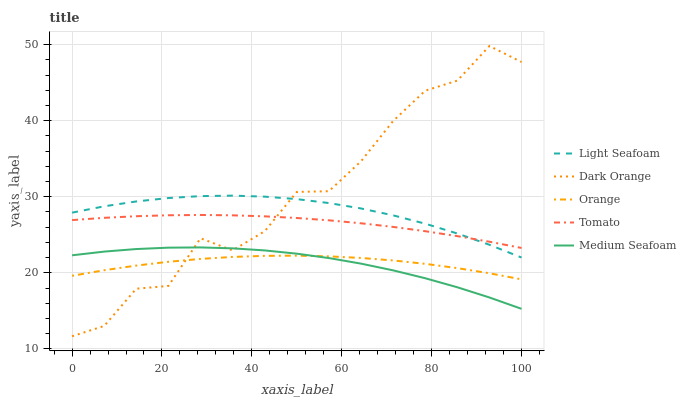Does Medium Seafoam have the minimum area under the curve?
Answer yes or no. Yes. Does Dark Orange have the maximum area under the curve?
Answer yes or no. Yes. Does Tomato have the minimum area under the curve?
Answer yes or no. No. Does Tomato have the maximum area under the curve?
Answer yes or no. No. Is Tomato the smoothest?
Answer yes or no. Yes. Is Dark Orange the roughest?
Answer yes or no. Yes. Is Dark Orange the smoothest?
Answer yes or no. No. Is Tomato the roughest?
Answer yes or no. No. Does Dark Orange have the lowest value?
Answer yes or no. Yes. Does Tomato have the lowest value?
Answer yes or no. No. Does Dark Orange have the highest value?
Answer yes or no. Yes. Does Tomato have the highest value?
Answer yes or no. No. Is Orange less than Light Seafoam?
Answer yes or no. Yes. Is Tomato greater than Medium Seafoam?
Answer yes or no. Yes. Does Orange intersect Dark Orange?
Answer yes or no. Yes. Is Orange less than Dark Orange?
Answer yes or no. No. Is Orange greater than Dark Orange?
Answer yes or no. No. Does Orange intersect Light Seafoam?
Answer yes or no. No. 